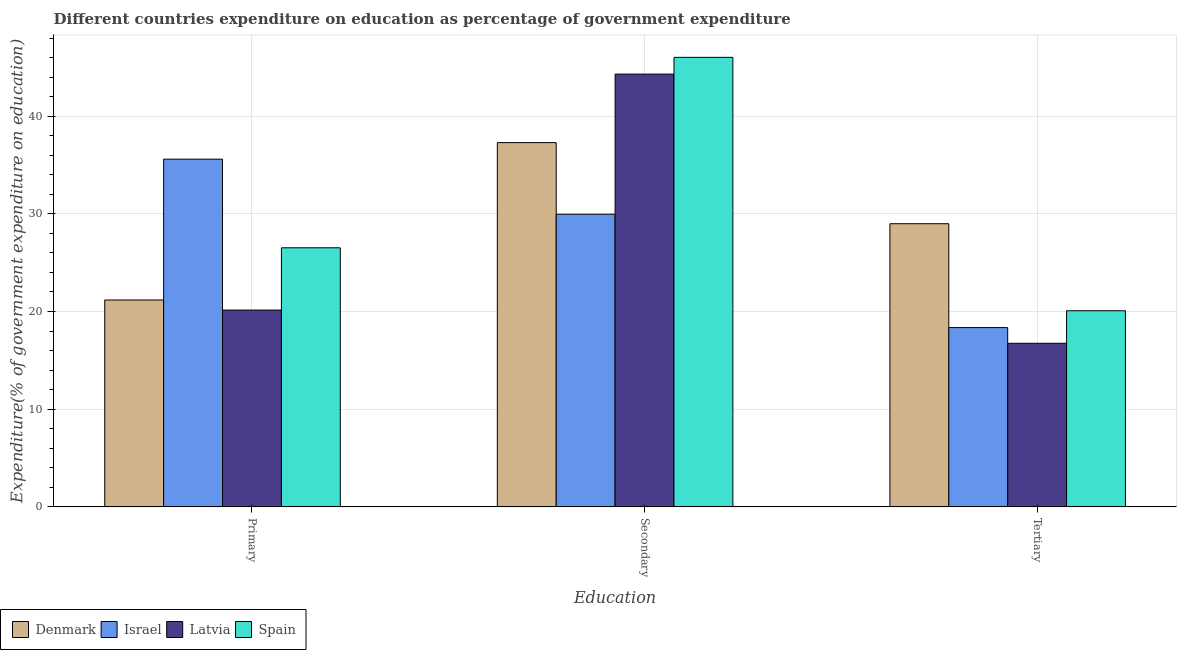How many groups of bars are there?
Your answer should be very brief. 3. Are the number of bars per tick equal to the number of legend labels?
Offer a terse response. Yes. How many bars are there on the 2nd tick from the left?
Make the answer very short. 4. What is the label of the 2nd group of bars from the left?
Provide a succinct answer. Secondary. What is the expenditure on primary education in Spain?
Your response must be concise. 26.53. Across all countries, what is the maximum expenditure on tertiary education?
Keep it short and to the point. 28.99. Across all countries, what is the minimum expenditure on primary education?
Provide a short and direct response. 20.15. In which country was the expenditure on secondary education maximum?
Keep it short and to the point. Spain. In which country was the expenditure on primary education minimum?
Your response must be concise. Latvia. What is the total expenditure on primary education in the graph?
Offer a terse response. 103.45. What is the difference between the expenditure on primary education in Israel and that in Spain?
Your answer should be very brief. 9.07. What is the difference between the expenditure on primary education in Israel and the expenditure on tertiary education in Denmark?
Keep it short and to the point. 6.61. What is the average expenditure on secondary education per country?
Provide a succinct answer. 39.4. What is the difference between the expenditure on primary education and expenditure on tertiary education in Denmark?
Make the answer very short. -7.81. In how many countries, is the expenditure on secondary education greater than 16 %?
Your answer should be very brief. 4. What is the ratio of the expenditure on primary education in Denmark to that in Israel?
Ensure brevity in your answer.  0.59. Is the expenditure on tertiary education in Denmark less than that in Spain?
Offer a terse response. No. Is the difference between the expenditure on primary education in Denmark and Latvia greater than the difference between the expenditure on tertiary education in Denmark and Latvia?
Offer a terse response. No. What is the difference between the highest and the second highest expenditure on secondary education?
Provide a short and direct response. 1.71. What is the difference between the highest and the lowest expenditure on tertiary education?
Make the answer very short. 12.24. What does the 1st bar from the left in Primary represents?
Give a very brief answer. Denmark. How many bars are there?
Provide a succinct answer. 12. Are all the bars in the graph horizontal?
Ensure brevity in your answer.  No. How many countries are there in the graph?
Your response must be concise. 4. Does the graph contain any zero values?
Offer a very short reply. No. Does the graph contain grids?
Make the answer very short. Yes. How are the legend labels stacked?
Your response must be concise. Horizontal. What is the title of the graph?
Keep it short and to the point. Different countries expenditure on education as percentage of government expenditure. Does "Australia" appear as one of the legend labels in the graph?
Provide a short and direct response. No. What is the label or title of the X-axis?
Offer a very short reply. Education. What is the label or title of the Y-axis?
Offer a terse response. Expenditure(% of government expenditure on education). What is the Expenditure(% of government expenditure on education) of Denmark in Primary?
Give a very brief answer. 21.18. What is the Expenditure(% of government expenditure on education) of Israel in Primary?
Your answer should be compact. 35.6. What is the Expenditure(% of government expenditure on education) in Latvia in Primary?
Ensure brevity in your answer.  20.15. What is the Expenditure(% of government expenditure on education) in Spain in Primary?
Offer a very short reply. 26.53. What is the Expenditure(% of government expenditure on education) in Denmark in Secondary?
Offer a terse response. 37.29. What is the Expenditure(% of government expenditure on education) in Israel in Secondary?
Offer a terse response. 29.96. What is the Expenditure(% of government expenditure on education) of Latvia in Secondary?
Ensure brevity in your answer.  44.31. What is the Expenditure(% of government expenditure on education) of Spain in Secondary?
Provide a short and direct response. 46.02. What is the Expenditure(% of government expenditure on education) in Denmark in Tertiary?
Give a very brief answer. 28.99. What is the Expenditure(% of government expenditure on education) of Israel in Tertiary?
Provide a succinct answer. 18.36. What is the Expenditure(% of government expenditure on education) of Latvia in Tertiary?
Give a very brief answer. 16.75. What is the Expenditure(% of government expenditure on education) in Spain in Tertiary?
Give a very brief answer. 20.08. Across all Education, what is the maximum Expenditure(% of government expenditure on education) in Denmark?
Make the answer very short. 37.29. Across all Education, what is the maximum Expenditure(% of government expenditure on education) of Israel?
Your answer should be very brief. 35.6. Across all Education, what is the maximum Expenditure(% of government expenditure on education) in Latvia?
Provide a short and direct response. 44.31. Across all Education, what is the maximum Expenditure(% of government expenditure on education) in Spain?
Your answer should be compact. 46.02. Across all Education, what is the minimum Expenditure(% of government expenditure on education) in Denmark?
Provide a short and direct response. 21.18. Across all Education, what is the minimum Expenditure(% of government expenditure on education) of Israel?
Offer a terse response. 18.36. Across all Education, what is the minimum Expenditure(% of government expenditure on education) of Latvia?
Offer a terse response. 16.75. Across all Education, what is the minimum Expenditure(% of government expenditure on education) in Spain?
Give a very brief answer. 20.08. What is the total Expenditure(% of government expenditure on education) of Denmark in the graph?
Provide a succinct answer. 87.46. What is the total Expenditure(% of government expenditure on education) in Israel in the graph?
Your answer should be compact. 83.92. What is the total Expenditure(% of government expenditure on education) of Latvia in the graph?
Your response must be concise. 81.2. What is the total Expenditure(% of government expenditure on education) of Spain in the graph?
Provide a succinct answer. 92.63. What is the difference between the Expenditure(% of government expenditure on education) in Denmark in Primary and that in Secondary?
Your response must be concise. -16.11. What is the difference between the Expenditure(% of government expenditure on education) in Israel in Primary and that in Secondary?
Keep it short and to the point. 5.64. What is the difference between the Expenditure(% of government expenditure on education) in Latvia in Primary and that in Secondary?
Provide a succinct answer. -24.16. What is the difference between the Expenditure(% of government expenditure on education) in Spain in Primary and that in Secondary?
Your answer should be compact. -19.5. What is the difference between the Expenditure(% of government expenditure on education) of Denmark in Primary and that in Tertiary?
Offer a terse response. -7.81. What is the difference between the Expenditure(% of government expenditure on education) of Israel in Primary and that in Tertiary?
Give a very brief answer. 17.24. What is the difference between the Expenditure(% of government expenditure on education) in Latvia in Primary and that in Tertiary?
Make the answer very short. 3.4. What is the difference between the Expenditure(% of government expenditure on education) in Spain in Primary and that in Tertiary?
Your response must be concise. 6.45. What is the difference between the Expenditure(% of government expenditure on education) in Denmark in Secondary and that in Tertiary?
Provide a short and direct response. 8.3. What is the difference between the Expenditure(% of government expenditure on education) in Israel in Secondary and that in Tertiary?
Give a very brief answer. 11.61. What is the difference between the Expenditure(% of government expenditure on education) of Latvia in Secondary and that in Tertiary?
Offer a very short reply. 27.56. What is the difference between the Expenditure(% of government expenditure on education) of Spain in Secondary and that in Tertiary?
Your answer should be very brief. 25.94. What is the difference between the Expenditure(% of government expenditure on education) of Denmark in Primary and the Expenditure(% of government expenditure on education) of Israel in Secondary?
Your answer should be very brief. -8.78. What is the difference between the Expenditure(% of government expenditure on education) of Denmark in Primary and the Expenditure(% of government expenditure on education) of Latvia in Secondary?
Your response must be concise. -23.13. What is the difference between the Expenditure(% of government expenditure on education) in Denmark in Primary and the Expenditure(% of government expenditure on education) in Spain in Secondary?
Your response must be concise. -24.84. What is the difference between the Expenditure(% of government expenditure on education) of Israel in Primary and the Expenditure(% of government expenditure on education) of Latvia in Secondary?
Your response must be concise. -8.71. What is the difference between the Expenditure(% of government expenditure on education) in Israel in Primary and the Expenditure(% of government expenditure on education) in Spain in Secondary?
Provide a short and direct response. -10.42. What is the difference between the Expenditure(% of government expenditure on education) of Latvia in Primary and the Expenditure(% of government expenditure on education) of Spain in Secondary?
Keep it short and to the point. -25.88. What is the difference between the Expenditure(% of government expenditure on education) of Denmark in Primary and the Expenditure(% of government expenditure on education) of Israel in Tertiary?
Your answer should be very brief. 2.82. What is the difference between the Expenditure(% of government expenditure on education) of Denmark in Primary and the Expenditure(% of government expenditure on education) of Latvia in Tertiary?
Offer a terse response. 4.43. What is the difference between the Expenditure(% of government expenditure on education) of Denmark in Primary and the Expenditure(% of government expenditure on education) of Spain in Tertiary?
Ensure brevity in your answer.  1.1. What is the difference between the Expenditure(% of government expenditure on education) in Israel in Primary and the Expenditure(% of government expenditure on education) in Latvia in Tertiary?
Provide a succinct answer. 18.85. What is the difference between the Expenditure(% of government expenditure on education) of Israel in Primary and the Expenditure(% of government expenditure on education) of Spain in Tertiary?
Provide a short and direct response. 15.52. What is the difference between the Expenditure(% of government expenditure on education) of Latvia in Primary and the Expenditure(% of government expenditure on education) of Spain in Tertiary?
Ensure brevity in your answer.  0.07. What is the difference between the Expenditure(% of government expenditure on education) in Denmark in Secondary and the Expenditure(% of government expenditure on education) in Israel in Tertiary?
Offer a very short reply. 18.94. What is the difference between the Expenditure(% of government expenditure on education) in Denmark in Secondary and the Expenditure(% of government expenditure on education) in Latvia in Tertiary?
Keep it short and to the point. 20.54. What is the difference between the Expenditure(% of government expenditure on education) of Denmark in Secondary and the Expenditure(% of government expenditure on education) of Spain in Tertiary?
Ensure brevity in your answer.  17.21. What is the difference between the Expenditure(% of government expenditure on education) of Israel in Secondary and the Expenditure(% of government expenditure on education) of Latvia in Tertiary?
Provide a succinct answer. 13.21. What is the difference between the Expenditure(% of government expenditure on education) in Israel in Secondary and the Expenditure(% of government expenditure on education) in Spain in Tertiary?
Provide a short and direct response. 9.88. What is the difference between the Expenditure(% of government expenditure on education) of Latvia in Secondary and the Expenditure(% of government expenditure on education) of Spain in Tertiary?
Offer a terse response. 24.23. What is the average Expenditure(% of government expenditure on education) of Denmark per Education?
Provide a succinct answer. 29.15. What is the average Expenditure(% of government expenditure on education) of Israel per Education?
Your answer should be very brief. 27.97. What is the average Expenditure(% of government expenditure on education) in Latvia per Education?
Your answer should be very brief. 27.07. What is the average Expenditure(% of government expenditure on education) of Spain per Education?
Offer a terse response. 30.88. What is the difference between the Expenditure(% of government expenditure on education) in Denmark and Expenditure(% of government expenditure on education) in Israel in Primary?
Make the answer very short. -14.42. What is the difference between the Expenditure(% of government expenditure on education) in Denmark and Expenditure(% of government expenditure on education) in Latvia in Primary?
Ensure brevity in your answer.  1.03. What is the difference between the Expenditure(% of government expenditure on education) of Denmark and Expenditure(% of government expenditure on education) of Spain in Primary?
Ensure brevity in your answer.  -5.35. What is the difference between the Expenditure(% of government expenditure on education) of Israel and Expenditure(% of government expenditure on education) of Latvia in Primary?
Keep it short and to the point. 15.45. What is the difference between the Expenditure(% of government expenditure on education) of Israel and Expenditure(% of government expenditure on education) of Spain in Primary?
Give a very brief answer. 9.07. What is the difference between the Expenditure(% of government expenditure on education) of Latvia and Expenditure(% of government expenditure on education) of Spain in Primary?
Keep it short and to the point. -6.38. What is the difference between the Expenditure(% of government expenditure on education) of Denmark and Expenditure(% of government expenditure on education) of Israel in Secondary?
Offer a terse response. 7.33. What is the difference between the Expenditure(% of government expenditure on education) of Denmark and Expenditure(% of government expenditure on education) of Latvia in Secondary?
Keep it short and to the point. -7.02. What is the difference between the Expenditure(% of government expenditure on education) in Denmark and Expenditure(% of government expenditure on education) in Spain in Secondary?
Make the answer very short. -8.73. What is the difference between the Expenditure(% of government expenditure on education) in Israel and Expenditure(% of government expenditure on education) in Latvia in Secondary?
Your answer should be very brief. -14.35. What is the difference between the Expenditure(% of government expenditure on education) of Israel and Expenditure(% of government expenditure on education) of Spain in Secondary?
Offer a very short reply. -16.06. What is the difference between the Expenditure(% of government expenditure on education) of Latvia and Expenditure(% of government expenditure on education) of Spain in Secondary?
Offer a terse response. -1.71. What is the difference between the Expenditure(% of government expenditure on education) in Denmark and Expenditure(% of government expenditure on education) in Israel in Tertiary?
Provide a succinct answer. 10.63. What is the difference between the Expenditure(% of government expenditure on education) in Denmark and Expenditure(% of government expenditure on education) in Latvia in Tertiary?
Your answer should be very brief. 12.24. What is the difference between the Expenditure(% of government expenditure on education) in Denmark and Expenditure(% of government expenditure on education) in Spain in Tertiary?
Offer a terse response. 8.91. What is the difference between the Expenditure(% of government expenditure on education) in Israel and Expenditure(% of government expenditure on education) in Latvia in Tertiary?
Your answer should be very brief. 1.61. What is the difference between the Expenditure(% of government expenditure on education) of Israel and Expenditure(% of government expenditure on education) of Spain in Tertiary?
Give a very brief answer. -1.72. What is the difference between the Expenditure(% of government expenditure on education) in Latvia and Expenditure(% of government expenditure on education) in Spain in Tertiary?
Provide a succinct answer. -3.33. What is the ratio of the Expenditure(% of government expenditure on education) of Denmark in Primary to that in Secondary?
Provide a short and direct response. 0.57. What is the ratio of the Expenditure(% of government expenditure on education) of Israel in Primary to that in Secondary?
Your answer should be compact. 1.19. What is the ratio of the Expenditure(% of government expenditure on education) in Latvia in Primary to that in Secondary?
Offer a terse response. 0.45. What is the ratio of the Expenditure(% of government expenditure on education) of Spain in Primary to that in Secondary?
Keep it short and to the point. 0.58. What is the ratio of the Expenditure(% of government expenditure on education) of Denmark in Primary to that in Tertiary?
Offer a very short reply. 0.73. What is the ratio of the Expenditure(% of government expenditure on education) in Israel in Primary to that in Tertiary?
Your answer should be very brief. 1.94. What is the ratio of the Expenditure(% of government expenditure on education) in Latvia in Primary to that in Tertiary?
Keep it short and to the point. 1.2. What is the ratio of the Expenditure(% of government expenditure on education) in Spain in Primary to that in Tertiary?
Provide a succinct answer. 1.32. What is the ratio of the Expenditure(% of government expenditure on education) of Denmark in Secondary to that in Tertiary?
Offer a very short reply. 1.29. What is the ratio of the Expenditure(% of government expenditure on education) in Israel in Secondary to that in Tertiary?
Keep it short and to the point. 1.63. What is the ratio of the Expenditure(% of government expenditure on education) of Latvia in Secondary to that in Tertiary?
Your response must be concise. 2.65. What is the ratio of the Expenditure(% of government expenditure on education) in Spain in Secondary to that in Tertiary?
Your answer should be compact. 2.29. What is the difference between the highest and the second highest Expenditure(% of government expenditure on education) of Denmark?
Ensure brevity in your answer.  8.3. What is the difference between the highest and the second highest Expenditure(% of government expenditure on education) in Israel?
Ensure brevity in your answer.  5.64. What is the difference between the highest and the second highest Expenditure(% of government expenditure on education) of Latvia?
Give a very brief answer. 24.16. What is the difference between the highest and the second highest Expenditure(% of government expenditure on education) in Spain?
Your answer should be very brief. 19.5. What is the difference between the highest and the lowest Expenditure(% of government expenditure on education) in Denmark?
Make the answer very short. 16.11. What is the difference between the highest and the lowest Expenditure(% of government expenditure on education) of Israel?
Make the answer very short. 17.24. What is the difference between the highest and the lowest Expenditure(% of government expenditure on education) of Latvia?
Your response must be concise. 27.56. What is the difference between the highest and the lowest Expenditure(% of government expenditure on education) in Spain?
Make the answer very short. 25.94. 